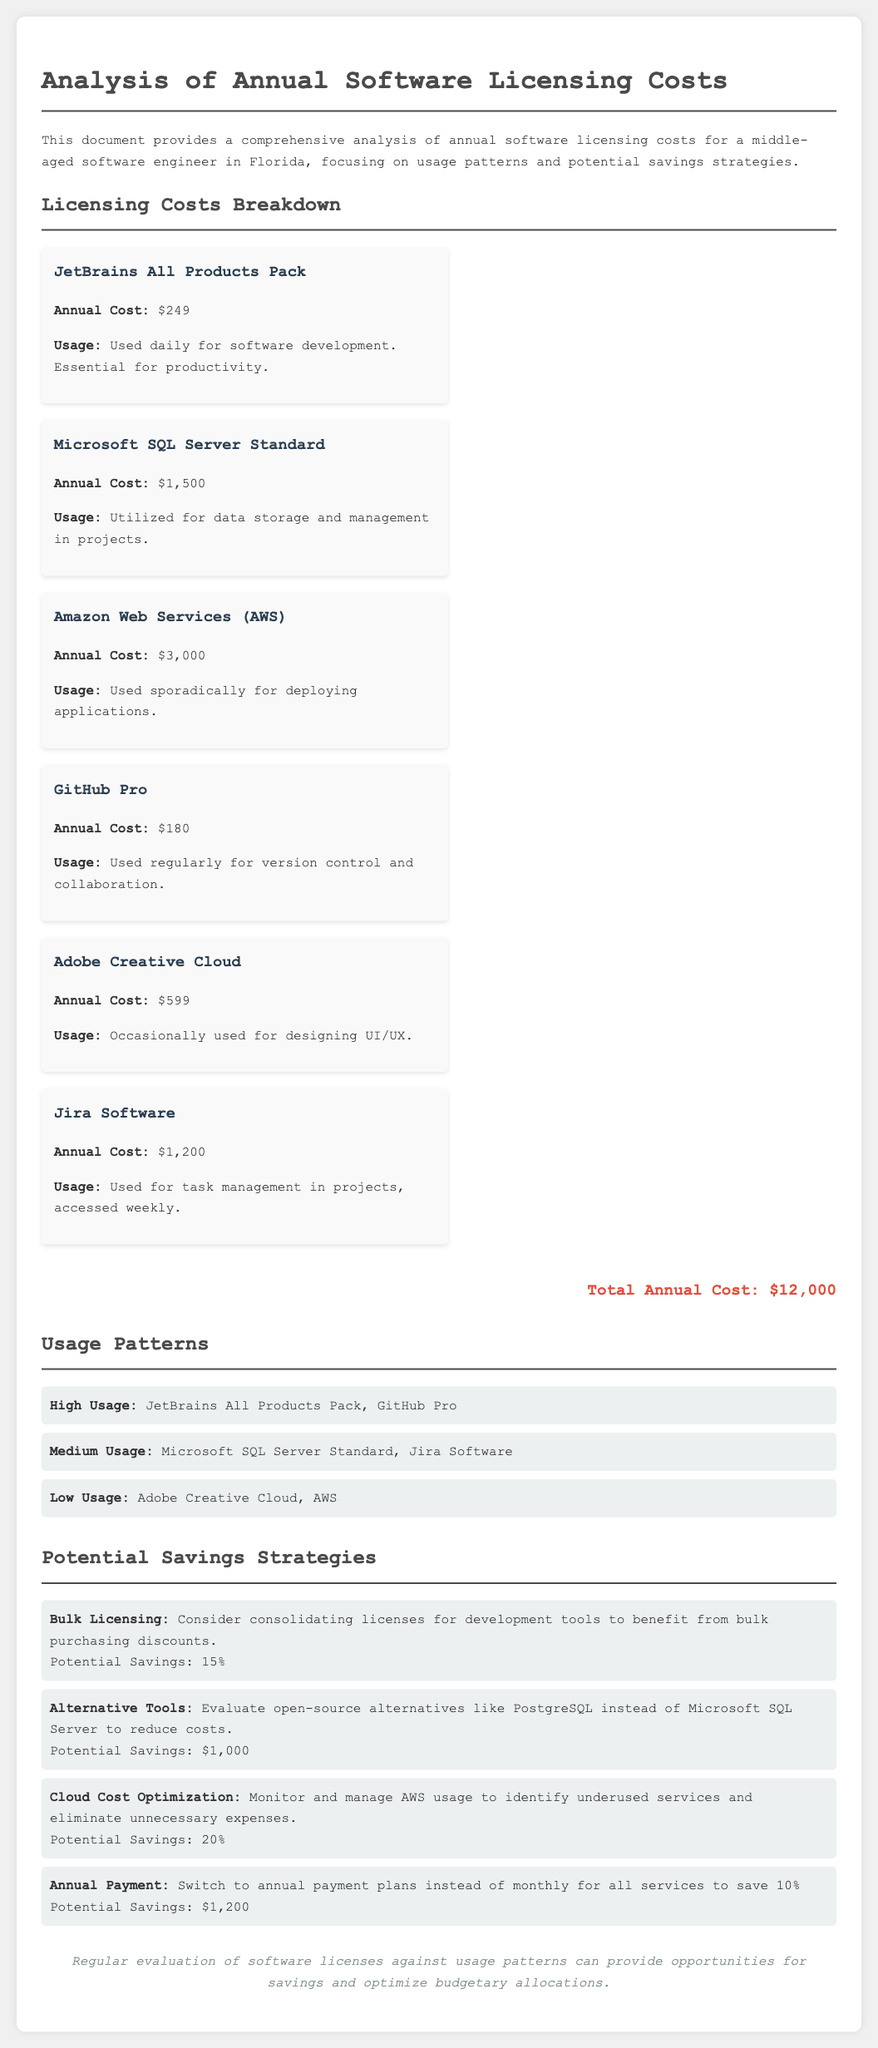What is the total annual cost? The total annual cost is presented at the bottom of the document, summing up all licensing costs, which is $12,000.
Answer: $12,000 What is the annual cost of Microsoft SQL Server Standard? The document highlights Microsoft SQL Server Standard's annual cost clearly, which is $1,500.
Answer: $1,500 Which software is used daily for software development? The document states that JetBrains All Products Pack is used daily for software development, emphasizing its essential role for productivity.
Answer: JetBrains All Products Pack What potential savings percentage can be achieved through bulk licensing? The potential savings through bulk licensing is explicitly mentioned in the document as 15%.
Answer: 15% Which software has low usage according to the document? The document categorizes Adobe Creative Cloud and AWS as having low usage, indicating their infrequent use.
Answer: Adobe Creative Cloud, AWS What is the potential saving by switching to annual payment plans? The document details that switching to annual payment plans for all services could save $1,200.
Answer: $1,200 What tool is suggested as an alternative to Microsoft SQL Server? The document recommends evaluating PostgreSQL as an alternative to Microsoft SQL Server to reduce costs.
Answer: PostgreSQL How often is Jira Software used? According to the document, Jira Software is accessed weekly, reflecting its periodic use in projects.
Answer: Weekly 